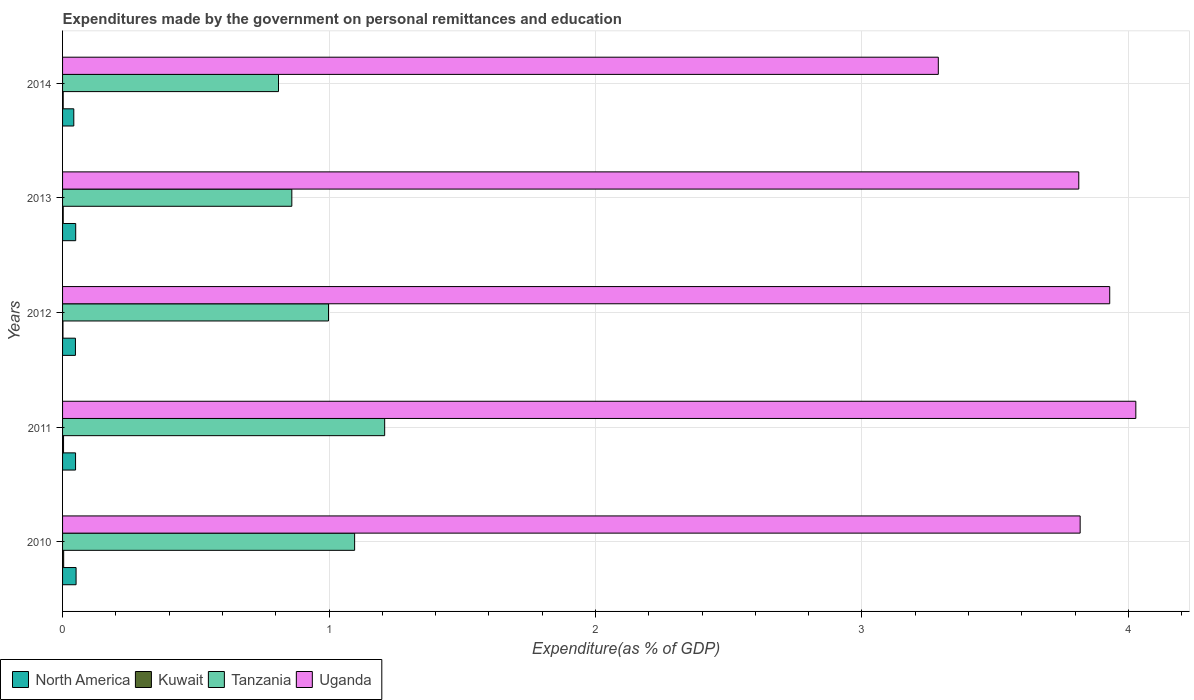Are the number of bars per tick equal to the number of legend labels?
Your answer should be very brief. Yes. What is the label of the 4th group of bars from the top?
Offer a very short reply. 2011. What is the expenditures made by the government on personal remittances and education in Tanzania in 2010?
Provide a succinct answer. 1.1. Across all years, what is the maximum expenditures made by the government on personal remittances and education in Tanzania?
Give a very brief answer. 1.21. Across all years, what is the minimum expenditures made by the government on personal remittances and education in Tanzania?
Keep it short and to the point. 0.81. In which year was the expenditures made by the government on personal remittances and education in Tanzania minimum?
Offer a terse response. 2014. What is the total expenditures made by the government on personal remittances and education in North America in the graph?
Ensure brevity in your answer.  0.24. What is the difference between the expenditures made by the government on personal remittances and education in Uganda in 2010 and that in 2013?
Make the answer very short. 0.01. What is the difference between the expenditures made by the government on personal remittances and education in Kuwait in 2010 and the expenditures made by the government on personal remittances and education in Tanzania in 2011?
Make the answer very short. -1.2. What is the average expenditures made by the government on personal remittances and education in Uganda per year?
Your answer should be very brief. 3.78. In the year 2013, what is the difference between the expenditures made by the government on personal remittances and education in Tanzania and expenditures made by the government on personal remittances and education in Kuwait?
Your answer should be very brief. 0.86. What is the ratio of the expenditures made by the government on personal remittances and education in Tanzania in 2011 to that in 2012?
Keep it short and to the point. 1.21. Is the expenditures made by the government on personal remittances and education in Kuwait in 2013 less than that in 2014?
Offer a very short reply. No. Is the difference between the expenditures made by the government on personal remittances and education in Tanzania in 2010 and 2013 greater than the difference between the expenditures made by the government on personal remittances and education in Kuwait in 2010 and 2013?
Offer a very short reply. Yes. What is the difference between the highest and the second highest expenditures made by the government on personal remittances and education in Uganda?
Make the answer very short. 0.1. What is the difference between the highest and the lowest expenditures made by the government on personal remittances and education in Kuwait?
Your answer should be compact. 0. Is the sum of the expenditures made by the government on personal remittances and education in North America in 2013 and 2014 greater than the maximum expenditures made by the government on personal remittances and education in Tanzania across all years?
Your answer should be very brief. No. Is it the case that in every year, the sum of the expenditures made by the government on personal remittances and education in Uganda and expenditures made by the government on personal remittances and education in Tanzania is greater than the sum of expenditures made by the government on personal remittances and education in Kuwait and expenditures made by the government on personal remittances and education in North America?
Provide a succinct answer. Yes. What does the 3rd bar from the top in 2011 represents?
Your answer should be very brief. Kuwait. What does the 3rd bar from the bottom in 2010 represents?
Your response must be concise. Tanzania. Does the graph contain grids?
Ensure brevity in your answer.  Yes. How are the legend labels stacked?
Give a very brief answer. Horizontal. What is the title of the graph?
Offer a very short reply. Expenditures made by the government on personal remittances and education. What is the label or title of the X-axis?
Your answer should be compact. Expenditure(as % of GDP). What is the Expenditure(as % of GDP) of North America in 2010?
Give a very brief answer. 0.05. What is the Expenditure(as % of GDP) in Kuwait in 2010?
Offer a very short reply. 0. What is the Expenditure(as % of GDP) of Tanzania in 2010?
Ensure brevity in your answer.  1.1. What is the Expenditure(as % of GDP) of Uganda in 2010?
Keep it short and to the point. 3.82. What is the Expenditure(as % of GDP) of North America in 2011?
Provide a succinct answer. 0.05. What is the Expenditure(as % of GDP) of Kuwait in 2011?
Your answer should be compact. 0. What is the Expenditure(as % of GDP) in Tanzania in 2011?
Offer a very short reply. 1.21. What is the Expenditure(as % of GDP) in Uganda in 2011?
Offer a terse response. 4.03. What is the Expenditure(as % of GDP) in North America in 2012?
Your answer should be very brief. 0.05. What is the Expenditure(as % of GDP) in Kuwait in 2012?
Give a very brief answer. 0. What is the Expenditure(as % of GDP) of Tanzania in 2012?
Your answer should be compact. 1. What is the Expenditure(as % of GDP) in Uganda in 2012?
Provide a succinct answer. 3.93. What is the Expenditure(as % of GDP) of North America in 2013?
Keep it short and to the point. 0.05. What is the Expenditure(as % of GDP) in Kuwait in 2013?
Ensure brevity in your answer.  0. What is the Expenditure(as % of GDP) of Tanzania in 2013?
Give a very brief answer. 0.86. What is the Expenditure(as % of GDP) in Uganda in 2013?
Make the answer very short. 3.81. What is the Expenditure(as % of GDP) in North America in 2014?
Your answer should be very brief. 0.04. What is the Expenditure(as % of GDP) of Kuwait in 2014?
Provide a succinct answer. 0. What is the Expenditure(as % of GDP) of Tanzania in 2014?
Provide a succinct answer. 0.81. What is the Expenditure(as % of GDP) of Uganda in 2014?
Your answer should be compact. 3.29. Across all years, what is the maximum Expenditure(as % of GDP) in North America?
Your response must be concise. 0.05. Across all years, what is the maximum Expenditure(as % of GDP) in Kuwait?
Ensure brevity in your answer.  0. Across all years, what is the maximum Expenditure(as % of GDP) in Tanzania?
Offer a terse response. 1.21. Across all years, what is the maximum Expenditure(as % of GDP) of Uganda?
Make the answer very short. 4.03. Across all years, what is the minimum Expenditure(as % of GDP) of North America?
Offer a terse response. 0.04. Across all years, what is the minimum Expenditure(as % of GDP) in Kuwait?
Offer a terse response. 0. Across all years, what is the minimum Expenditure(as % of GDP) of Tanzania?
Your answer should be compact. 0.81. Across all years, what is the minimum Expenditure(as % of GDP) of Uganda?
Your response must be concise. 3.29. What is the total Expenditure(as % of GDP) of North America in the graph?
Keep it short and to the point. 0.24. What is the total Expenditure(as % of GDP) in Kuwait in the graph?
Keep it short and to the point. 0.01. What is the total Expenditure(as % of GDP) in Tanzania in the graph?
Give a very brief answer. 4.97. What is the total Expenditure(as % of GDP) in Uganda in the graph?
Provide a succinct answer. 18.88. What is the difference between the Expenditure(as % of GDP) of North America in 2010 and that in 2011?
Your response must be concise. 0. What is the difference between the Expenditure(as % of GDP) in Kuwait in 2010 and that in 2011?
Provide a short and direct response. 0. What is the difference between the Expenditure(as % of GDP) in Tanzania in 2010 and that in 2011?
Offer a terse response. -0.11. What is the difference between the Expenditure(as % of GDP) of Uganda in 2010 and that in 2011?
Your answer should be very brief. -0.21. What is the difference between the Expenditure(as % of GDP) in North America in 2010 and that in 2012?
Provide a succinct answer. 0. What is the difference between the Expenditure(as % of GDP) in Kuwait in 2010 and that in 2012?
Ensure brevity in your answer.  0. What is the difference between the Expenditure(as % of GDP) in Tanzania in 2010 and that in 2012?
Provide a short and direct response. 0.1. What is the difference between the Expenditure(as % of GDP) of Uganda in 2010 and that in 2012?
Ensure brevity in your answer.  -0.11. What is the difference between the Expenditure(as % of GDP) in North America in 2010 and that in 2013?
Ensure brevity in your answer.  0. What is the difference between the Expenditure(as % of GDP) in Kuwait in 2010 and that in 2013?
Make the answer very short. 0. What is the difference between the Expenditure(as % of GDP) in Tanzania in 2010 and that in 2013?
Provide a succinct answer. 0.24. What is the difference between the Expenditure(as % of GDP) of Uganda in 2010 and that in 2013?
Keep it short and to the point. 0.01. What is the difference between the Expenditure(as % of GDP) of North America in 2010 and that in 2014?
Provide a short and direct response. 0.01. What is the difference between the Expenditure(as % of GDP) of Kuwait in 2010 and that in 2014?
Your response must be concise. 0. What is the difference between the Expenditure(as % of GDP) in Tanzania in 2010 and that in 2014?
Give a very brief answer. 0.29. What is the difference between the Expenditure(as % of GDP) in Uganda in 2010 and that in 2014?
Your response must be concise. 0.53. What is the difference between the Expenditure(as % of GDP) in Kuwait in 2011 and that in 2012?
Make the answer very short. 0. What is the difference between the Expenditure(as % of GDP) of Tanzania in 2011 and that in 2012?
Your response must be concise. 0.21. What is the difference between the Expenditure(as % of GDP) of Uganda in 2011 and that in 2012?
Give a very brief answer. 0.1. What is the difference between the Expenditure(as % of GDP) in North America in 2011 and that in 2013?
Your response must be concise. -0. What is the difference between the Expenditure(as % of GDP) in Kuwait in 2011 and that in 2013?
Give a very brief answer. 0. What is the difference between the Expenditure(as % of GDP) of Tanzania in 2011 and that in 2013?
Your answer should be compact. 0.35. What is the difference between the Expenditure(as % of GDP) in Uganda in 2011 and that in 2013?
Your response must be concise. 0.21. What is the difference between the Expenditure(as % of GDP) in North America in 2011 and that in 2014?
Offer a very short reply. 0.01. What is the difference between the Expenditure(as % of GDP) in Kuwait in 2011 and that in 2014?
Your response must be concise. 0. What is the difference between the Expenditure(as % of GDP) in Tanzania in 2011 and that in 2014?
Offer a terse response. 0.4. What is the difference between the Expenditure(as % of GDP) in Uganda in 2011 and that in 2014?
Offer a very short reply. 0.74. What is the difference between the Expenditure(as % of GDP) in North America in 2012 and that in 2013?
Offer a very short reply. -0. What is the difference between the Expenditure(as % of GDP) in Kuwait in 2012 and that in 2013?
Keep it short and to the point. -0. What is the difference between the Expenditure(as % of GDP) of Tanzania in 2012 and that in 2013?
Offer a very short reply. 0.14. What is the difference between the Expenditure(as % of GDP) in Uganda in 2012 and that in 2013?
Ensure brevity in your answer.  0.12. What is the difference between the Expenditure(as % of GDP) in North America in 2012 and that in 2014?
Offer a terse response. 0.01. What is the difference between the Expenditure(as % of GDP) of Kuwait in 2012 and that in 2014?
Make the answer very short. -0. What is the difference between the Expenditure(as % of GDP) of Tanzania in 2012 and that in 2014?
Offer a terse response. 0.19. What is the difference between the Expenditure(as % of GDP) in Uganda in 2012 and that in 2014?
Provide a succinct answer. 0.64. What is the difference between the Expenditure(as % of GDP) in North America in 2013 and that in 2014?
Your response must be concise. 0.01. What is the difference between the Expenditure(as % of GDP) in Tanzania in 2013 and that in 2014?
Provide a succinct answer. 0.05. What is the difference between the Expenditure(as % of GDP) of Uganda in 2013 and that in 2014?
Your answer should be compact. 0.53. What is the difference between the Expenditure(as % of GDP) of North America in 2010 and the Expenditure(as % of GDP) of Kuwait in 2011?
Offer a terse response. 0.05. What is the difference between the Expenditure(as % of GDP) of North America in 2010 and the Expenditure(as % of GDP) of Tanzania in 2011?
Ensure brevity in your answer.  -1.16. What is the difference between the Expenditure(as % of GDP) in North America in 2010 and the Expenditure(as % of GDP) in Uganda in 2011?
Ensure brevity in your answer.  -3.98. What is the difference between the Expenditure(as % of GDP) of Kuwait in 2010 and the Expenditure(as % of GDP) of Tanzania in 2011?
Your answer should be compact. -1.2. What is the difference between the Expenditure(as % of GDP) of Kuwait in 2010 and the Expenditure(as % of GDP) of Uganda in 2011?
Keep it short and to the point. -4.02. What is the difference between the Expenditure(as % of GDP) of Tanzania in 2010 and the Expenditure(as % of GDP) of Uganda in 2011?
Provide a short and direct response. -2.93. What is the difference between the Expenditure(as % of GDP) in North America in 2010 and the Expenditure(as % of GDP) in Kuwait in 2012?
Offer a very short reply. 0.05. What is the difference between the Expenditure(as % of GDP) in North America in 2010 and the Expenditure(as % of GDP) in Tanzania in 2012?
Offer a terse response. -0.95. What is the difference between the Expenditure(as % of GDP) of North America in 2010 and the Expenditure(as % of GDP) of Uganda in 2012?
Keep it short and to the point. -3.88. What is the difference between the Expenditure(as % of GDP) of Kuwait in 2010 and the Expenditure(as % of GDP) of Tanzania in 2012?
Offer a very short reply. -0.99. What is the difference between the Expenditure(as % of GDP) in Kuwait in 2010 and the Expenditure(as % of GDP) in Uganda in 2012?
Ensure brevity in your answer.  -3.93. What is the difference between the Expenditure(as % of GDP) of Tanzania in 2010 and the Expenditure(as % of GDP) of Uganda in 2012?
Your answer should be compact. -2.83. What is the difference between the Expenditure(as % of GDP) of North America in 2010 and the Expenditure(as % of GDP) of Kuwait in 2013?
Offer a very short reply. 0.05. What is the difference between the Expenditure(as % of GDP) of North America in 2010 and the Expenditure(as % of GDP) of Tanzania in 2013?
Your answer should be very brief. -0.81. What is the difference between the Expenditure(as % of GDP) of North America in 2010 and the Expenditure(as % of GDP) of Uganda in 2013?
Make the answer very short. -3.76. What is the difference between the Expenditure(as % of GDP) of Kuwait in 2010 and the Expenditure(as % of GDP) of Tanzania in 2013?
Offer a terse response. -0.86. What is the difference between the Expenditure(as % of GDP) in Kuwait in 2010 and the Expenditure(as % of GDP) in Uganda in 2013?
Offer a terse response. -3.81. What is the difference between the Expenditure(as % of GDP) in Tanzania in 2010 and the Expenditure(as % of GDP) in Uganda in 2013?
Make the answer very short. -2.72. What is the difference between the Expenditure(as % of GDP) in North America in 2010 and the Expenditure(as % of GDP) in Kuwait in 2014?
Ensure brevity in your answer.  0.05. What is the difference between the Expenditure(as % of GDP) in North America in 2010 and the Expenditure(as % of GDP) in Tanzania in 2014?
Offer a terse response. -0.76. What is the difference between the Expenditure(as % of GDP) in North America in 2010 and the Expenditure(as % of GDP) in Uganda in 2014?
Your answer should be very brief. -3.24. What is the difference between the Expenditure(as % of GDP) of Kuwait in 2010 and the Expenditure(as % of GDP) of Tanzania in 2014?
Provide a short and direct response. -0.81. What is the difference between the Expenditure(as % of GDP) in Kuwait in 2010 and the Expenditure(as % of GDP) in Uganda in 2014?
Your answer should be very brief. -3.28. What is the difference between the Expenditure(as % of GDP) in Tanzania in 2010 and the Expenditure(as % of GDP) in Uganda in 2014?
Offer a very short reply. -2.19. What is the difference between the Expenditure(as % of GDP) in North America in 2011 and the Expenditure(as % of GDP) in Kuwait in 2012?
Make the answer very short. 0.05. What is the difference between the Expenditure(as % of GDP) in North America in 2011 and the Expenditure(as % of GDP) in Tanzania in 2012?
Offer a very short reply. -0.95. What is the difference between the Expenditure(as % of GDP) of North America in 2011 and the Expenditure(as % of GDP) of Uganda in 2012?
Provide a short and direct response. -3.88. What is the difference between the Expenditure(as % of GDP) in Kuwait in 2011 and the Expenditure(as % of GDP) in Tanzania in 2012?
Your answer should be very brief. -0.99. What is the difference between the Expenditure(as % of GDP) in Kuwait in 2011 and the Expenditure(as % of GDP) in Uganda in 2012?
Provide a short and direct response. -3.93. What is the difference between the Expenditure(as % of GDP) in Tanzania in 2011 and the Expenditure(as % of GDP) in Uganda in 2012?
Provide a succinct answer. -2.72. What is the difference between the Expenditure(as % of GDP) of North America in 2011 and the Expenditure(as % of GDP) of Kuwait in 2013?
Ensure brevity in your answer.  0.05. What is the difference between the Expenditure(as % of GDP) in North America in 2011 and the Expenditure(as % of GDP) in Tanzania in 2013?
Provide a succinct answer. -0.81. What is the difference between the Expenditure(as % of GDP) of North America in 2011 and the Expenditure(as % of GDP) of Uganda in 2013?
Provide a short and direct response. -3.77. What is the difference between the Expenditure(as % of GDP) of Kuwait in 2011 and the Expenditure(as % of GDP) of Tanzania in 2013?
Make the answer very short. -0.86. What is the difference between the Expenditure(as % of GDP) of Kuwait in 2011 and the Expenditure(as % of GDP) of Uganda in 2013?
Make the answer very short. -3.81. What is the difference between the Expenditure(as % of GDP) in Tanzania in 2011 and the Expenditure(as % of GDP) in Uganda in 2013?
Keep it short and to the point. -2.61. What is the difference between the Expenditure(as % of GDP) of North America in 2011 and the Expenditure(as % of GDP) of Kuwait in 2014?
Keep it short and to the point. 0.05. What is the difference between the Expenditure(as % of GDP) of North America in 2011 and the Expenditure(as % of GDP) of Tanzania in 2014?
Your answer should be compact. -0.76. What is the difference between the Expenditure(as % of GDP) in North America in 2011 and the Expenditure(as % of GDP) in Uganda in 2014?
Offer a terse response. -3.24. What is the difference between the Expenditure(as % of GDP) in Kuwait in 2011 and the Expenditure(as % of GDP) in Tanzania in 2014?
Ensure brevity in your answer.  -0.81. What is the difference between the Expenditure(as % of GDP) in Kuwait in 2011 and the Expenditure(as % of GDP) in Uganda in 2014?
Give a very brief answer. -3.28. What is the difference between the Expenditure(as % of GDP) in Tanzania in 2011 and the Expenditure(as % of GDP) in Uganda in 2014?
Give a very brief answer. -2.08. What is the difference between the Expenditure(as % of GDP) of North America in 2012 and the Expenditure(as % of GDP) of Kuwait in 2013?
Make the answer very short. 0.05. What is the difference between the Expenditure(as % of GDP) of North America in 2012 and the Expenditure(as % of GDP) of Tanzania in 2013?
Offer a terse response. -0.81. What is the difference between the Expenditure(as % of GDP) in North America in 2012 and the Expenditure(as % of GDP) in Uganda in 2013?
Provide a succinct answer. -3.77. What is the difference between the Expenditure(as % of GDP) in Kuwait in 2012 and the Expenditure(as % of GDP) in Tanzania in 2013?
Provide a short and direct response. -0.86. What is the difference between the Expenditure(as % of GDP) of Kuwait in 2012 and the Expenditure(as % of GDP) of Uganda in 2013?
Offer a very short reply. -3.81. What is the difference between the Expenditure(as % of GDP) in Tanzania in 2012 and the Expenditure(as % of GDP) in Uganda in 2013?
Your response must be concise. -2.82. What is the difference between the Expenditure(as % of GDP) of North America in 2012 and the Expenditure(as % of GDP) of Kuwait in 2014?
Your answer should be compact. 0.05. What is the difference between the Expenditure(as % of GDP) in North America in 2012 and the Expenditure(as % of GDP) in Tanzania in 2014?
Provide a short and direct response. -0.76. What is the difference between the Expenditure(as % of GDP) of North America in 2012 and the Expenditure(as % of GDP) of Uganda in 2014?
Your answer should be very brief. -3.24. What is the difference between the Expenditure(as % of GDP) in Kuwait in 2012 and the Expenditure(as % of GDP) in Tanzania in 2014?
Your response must be concise. -0.81. What is the difference between the Expenditure(as % of GDP) of Kuwait in 2012 and the Expenditure(as % of GDP) of Uganda in 2014?
Your response must be concise. -3.29. What is the difference between the Expenditure(as % of GDP) in Tanzania in 2012 and the Expenditure(as % of GDP) in Uganda in 2014?
Keep it short and to the point. -2.29. What is the difference between the Expenditure(as % of GDP) in North America in 2013 and the Expenditure(as % of GDP) in Kuwait in 2014?
Provide a succinct answer. 0.05. What is the difference between the Expenditure(as % of GDP) of North America in 2013 and the Expenditure(as % of GDP) of Tanzania in 2014?
Offer a very short reply. -0.76. What is the difference between the Expenditure(as % of GDP) in North America in 2013 and the Expenditure(as % of GDP) in Uganda in 2014?
Provide a succinct answer. -3.24. What is the difference between the Expenditure(as % of GDP) of Kuwait in 2013 and the Expenditure(as % of GDP) of Tanzania in 2014?
Give a very brief answer. -0.81. What is the difference between the Expenditure(as % of GDP) in Kuwait in 2013 and the Expenditure(as % of GDP) in Uganda in 2014?
Ensure brevity in your answer.  -3.28. What is the difference between the Expenditure(as % of GDP) in Tanzania in 2013 and the Expenditure(as % of GDP) in Uganda in 2014?
Your response must be concise. -2.43. What is the average Expenditure(as % of GDP) in North America per year?
Your answer should be compact. 0.05. What is the average Expenditure(as % of GDP) in Kuwait per year?
Ensure brevity in your answer.  0. What is the average Expenditure(as % of GDP) of Uganda per year?
Ensure brevity in your answer.  3.78. In the year 2010, what is the difference between the Expenditure(as % of GDP) in North America and Expenditure(as % of GDP) in Kuwait?
Provide a short and direct response. 0.05. In the year 2010, what is the difference between the Expenditure(as % of GDP) of North America and Expenditure(as % of GDP) of Tanzania?
Make the answer very short. -1.05. In the year 2010, what is the difference between the Expenditure(as % of GDP) in North America and Expenditure(as % of GDP) in Uganda?
Make the answer very short. -3.77. In the year 2010, what is the difference between the Expenditure(as % of GDP) in Kuwait and Expenditure(as % of GDP) in Tanzania?
Your answer should be compact. -1.09. In the year 2010, what is the difference between the Expenditure(as % of GDP) in Kuwait and Expenditure(as % of GDP) in Uganda?
Provide a succinct answer. -3.82. In the year 2010, what is the difference between the Expenditure(as % of GDP) in Tanzania and Expenditure(as % of GDP) in Uganda?
Make the answer very short. -2.72. In the year 2011, what is the difference between the Expenditure(as % of GDP) of North America and Expenditure(as % of GDP) of Kuwait?
Provide a short and direct response. 0.05. In the year 2011, what is the difference between the Expenditure(as % of GDP) of North America and Expenditure(as % of GDP) of Tanzania?
Make the answer very short. -1.16. In the year 2011, what is the difference between the Expenditure(as % of GDP) in North America and Expenditure(as % of GDP) in Uganda?
Provide a short and direct response. -3.98. In the year 2011, what is the difference between the Expenditure(as % of GDP) of Kuwait and Expenditure(as % of GDP) of Tanzania?
Give a very brief answer. -1.21. In the year 2011, what is the difference between the Expenditure(as % of GDP) of Kuwait and Expenditure(as % of GDP) of Uganda?
Provide a short and direct response. -4.02. In the year 2011, what is the difference between the Expenditure(as % of GDP) in Tanzania and Expenditure(as % of GDP) in Uganda?
Offer a very short reply. -2.82. In the year 2012, what is the difference between the Expenditure(as % of GDP) in North America and Expenditure(as % of GDP) in Kuwait?
Give a very brief answer. 0.05. In the year 2012, what is the difference between the Expenditure(as % of GDP) of North America and Expenditure(as % of GDP) of Tanzania?
Your response must be concise. -0.95. In the year 2012, what is the difference between the Expenditure(as % of GDP) in North America and Expenditure(as % of GDP) in Uganda?
Your answer should be very brief. -3.88. In the year 2012, what is the difference between the Expenditure(as % of GDP) in Kuwait and Expenditure(as % of GDP) in Tanzania?
Offer a very short reply. -1. In the year 2012, what is the difference between the Expenditure(as % of GDP) of Kuwait and Expenditure(as % of GDP) of Uganda?
Your answer should be compact. -3.93. In the year 2012, what is the difference between the Expenditure(as % of GDP) of Tanzania and Expenditure(as % of GDP) of Uganda?
Your response must be concise. -2.93. In the year 2013, what is the difference between the Expenditure(as % of GDP) of North America and Expenditure(as % of GDP) of Kuwait?
Give a very brief answer. 0.05. In the year 2013, what is the difference between the Expenditure(as % of GDP) of North America and Expenditure(as % of GDP) of Tanzania?
Provide a succinct answer. -0.81. In the year 2013, what is the difference between the Expenditure(as % of GDP) of North America and Expenditure(as % of GDP) of Uganda?
Offer a very short reply. -3.76. In the year 2013, what is the difference between the Expenditure(as % of GDP) in Kuwait and Expenditure(as % of GDP) in Tanzania?
Give a very brief answer. -0.86. In the year 2013, what is the difference between the Expenditure(as % of GDP) in Kuwait and Expenditure(as % of GDP) in Uganda?
Ensure brevity in your answer.  -3.81. In the year 2013, what is the difference between the Expenditure(as % of GDP) of Tanzania and Expenditure(as % of GDP) of Uganda?
Your response must be concise. -2.95. In the year 2014, what is the difference between the Expenditure(as % of GDP) of North America and Expenditure(as % of GDP) of Kuwait?
Keep it short and to the point. 0.04. In the year 2014, what is the difference between the Expenditure(as % of GDP) in North America and Expenditure(as % of GDP) in Tanzania?
Offer a terse response. -0.77. In the year 2014, what is the difference between the Expenditure(as % of GDP) in North America and Expenditure(as % of GDP) in Uganda?
Your answer should be very brief. -3.24. In the year 2014, what is the difference between the Expenditure(as % of GDP) in Kuwait and Expenditure(as % of GDP) in Tanzania?
Your answer should be very brief. -0.81. In the year 2014, what is the difference between the Expenditure(as % of GDP) of Kuwait and Expenditure(as % of GDP) of Uganda?
Offer a very short reply. -3.28. In the year 2014, what is the difference between the Expenditure(as % of GDP) in Tanzania and Expenditure(as % of GDP) in Uganda?
Make the answer very short. -2.48. What is the ratio of the Expenditure(as % of GDP) in North America in 2010 to that in 2011?
Give a very brief answer. 1.04. What is the ratio of the Expenditure(as % of GDP) of Kuwait in 2010 to that in 2011?
Your response must be concise. 1.14. What is the ratio of the Expenditure(as % of GDP) in Tanzania in 2010 to that in 2011?
Your answer should be compact. 0.91. What is the ratio of the Expenditure(as % of GDP) in Uganda in 2010 to that in 2011?
Make the answer very short. 0.95. What is the ratio of the Expenditure(as % of GDP) in North America in 2010 to that in 2012?
Provide a succinct answer. 1.05. What is the ratio of the Expenditure(as % of GDP) of Kuwait in 2010 to that in 2012?
Your answer should be very brief. 2.77. What is the ratio of the Expenditure(as % of GDP) of Tanzania in 2010 to that in 2012?
Your answer should be very brief. 1.1. What is the ratio of the Expenditure(as % of GDP) of Uganda in 2010 to that in 2012?
Offer a very short reply. 0.97. What is the ratio of the Expenditure(as % of GDP) in North America in 2010 to that in 2013?
Provide a short and direct response. 1.03. What is the ratio of the Expenditure(as % of GDP) of Kuwait in 2010 to that in 2013?
Provide a short and direct response. 1.72. What is the ratio of the Expenditure(as % of GDP) of Tanzania in 2010 to that in 2013?
Your answer should be compact. 1.27. What is the ratio of the Expenditure(as % of GDP) of Uganda in 2010 to that in 2013?
Keep it short and to the point. 1. What is the ratio of the Expenditure(as % of GDP) in North America in 2010 to that in 2014?
Provide a succinct answer. 1.2. What is the ratio of the Expenditure(as % of GDP) in Kuwait in 2010 to that in 2014?
Make the answer very short. 1.78. What is the ratio of the Expenditure(as % of GDP) in Tanzania in 2010 to that in 2014?
Provide a succinct answer. 1.35. What is the ratio of the Expenditure(as % of GDP) of Uganda in 2010 to that in 2014?
Provide a short and direct response. 1.16. What is the ratio of the Expenditure(as % of GDP) in North America in 2011 to that in 2012?
Offer a terse response. 1.01. What is the ratio of the Expenditure(as % of GDP) in Kuwait in 2011 to that in 2012?
Keep it short and to the point. 2.44. What is the ratio of the Expenditure(as % of GDP) of Tanzania in 2011 to that in 2012?
Your answer should be compact. 1.21. What is the ratio of the Expenditure(as % of GDP) in Uganda in 2011 to that in 2012?
Give a very brief answer. 1.02. What is the ratio of the Expenditure(as % of GDP) of Kuwait in 2011 to that in 2013?
Offer a very short reply. 1.51. What is the ratio of the Expenditure(as % of GDP) in Tanzania in 2011 to that in 2013?
Offer a terse response. 1.4. What is the ratio of the Expenditure(as % of GDP) of Uganda in 2011 to that in 2013?
Provide a succinct answer. 1.06. What is the ratio of the Expenditure(as % of GDP) of North America in 2011 to that in 2014?
Offer a very short reply. 1.16. What is the ratio of the Expenditure(as % of GDP) in Kuwait in 2011 to that in 2014?
Provide a succinct answer. 1.56. What is the ratio of the Expenditure(as % of GDP) of Tanzania in 2011 to that in 2014?
Give a very brief answer. 1.49. What is the ratio of the Expenditure(as % of GDP) in Uganda in 2011 to that in 2014?
Ensure brevity in your answer.  1.23. What is the ratio of the Expenditure(as % of GDP) of North America in 2012 to that in 2013?
Ensure brevity in your answer.  0.98. What is the ratio of the Expenditure(as % of GDP) of Kuwait in 2012 to that in 2013?
Offer a very short reply. 0.62. What is the ratio of the Expenditure(as % of GDP) of Tanzania in 2012 to that in 2013?
Provide a short and direct response. 1.16. What is the ratio of the Expenditure(as % of GDP) in Uganda in 2012 to that in 2013?
Provide a short and direct response. 1.03. What is the ratio of the Expenditure(as % of GDP) in North America in 2012 to that in 2014?
Your response must be concise. 1.15. What is the ratio of the Expenditure(as % of GDP) in Kuwait in 2012 to that in 2014?
Offer a terse response. 0.64. What is the ratio of the Expenditure(as % of GDP) in Tanzania in 2012 to that in 2014?
Offer a very short reply. 1.23. What is the ratio of the Expenditure(as % of GDP) in Uganda in 2012 to that in 2014?
Provide a succinct answer. 1.2. What is the ratio of the Expenditure(as % of GDP) in North America in 2013 to that in 2014?
Give a very brief answer. 1.17. What is the ratio of the Expenditure(as % of GDP) of Kuwait in 2013 to that in 2014?
Offer a terse response. 1.03. What is the ratio of the Expenditure(as % of GDP) of Tanzania in 2013 to that in 2014?
Your response must be concise. 1.06. What is the ratio of the Expenditure(as % of GDP) of Uganda in 2013 to that in 2014?
Your answer should be compact. 1.16. What is the difference between the highest and the second highest Expenditure(as % of GDP) in North America?
Your answer should be compact. 0. What is the difference between the highest and the second highest Expenditure(as % of GDP) of Kuwait?
Give a very brief answer. 0. What is the difference between the highest and the second highest Expenditure(as % of GDP) of Tanzania?
Your answer should be compact. 0.11. What is the difference between the highest and the second highest Expenditure(as % of GDP) in Uganda?
Ensure brevity in your answer.  0.1. What is the difference between the highest and the lowest Expenditure(as % of GDP) in North America?
Your answer should be compact. 0.01. What is the difference between the highest and the lowest Expenditure(as % of GDP) of Kuwait?
Provide a short and direct response. 0. What is the difference between the highest and the lowest Expenditure(as % of GDP) in Tanzania?
Give a very brief answer. 0.4. What is the difference between the highest and the lowest Expenditure(as % of GDP) of Uganda?
Make the answer very short. 0.74. 